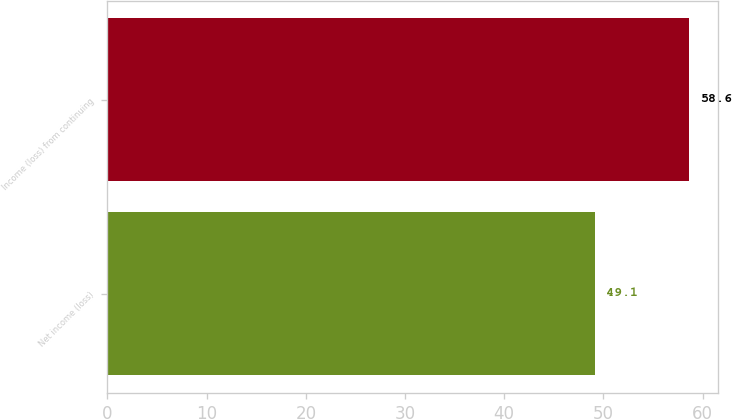<chart> <loc_0><loc_0><loc_500><loc_500><bar_chart><fcel>Net income (loss)<fcel>Income (loss) from continuing<nl><fcel>49.1<fcel>58.6<nl></chart> 